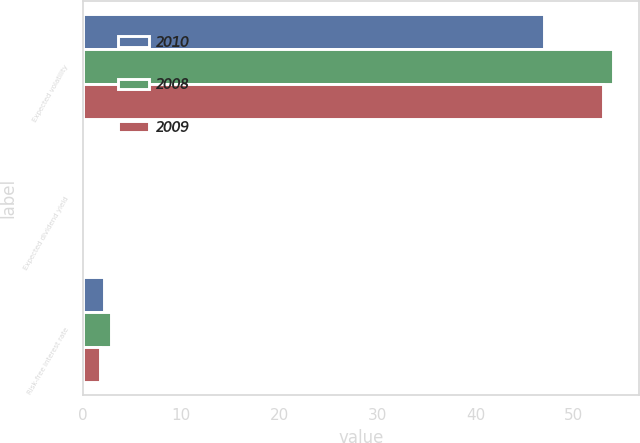Convert chart to OTSL. <chart><loc_0><loc_0><loc_500><loc_500><stacked_bar_chart><ecel><fcel>Expected volatility<fcel>Expected dividend yield<fcel>Risk-free interest rate<nl><fcel>2010<fcel>47<fcel>0<fcel>2.11<nl><fcel>2008<fcel>54<fcel>0<fcel>2.87<nl><fcel>2009<fcel>53<fcel>0<fcel>1.73<nl></chart> 